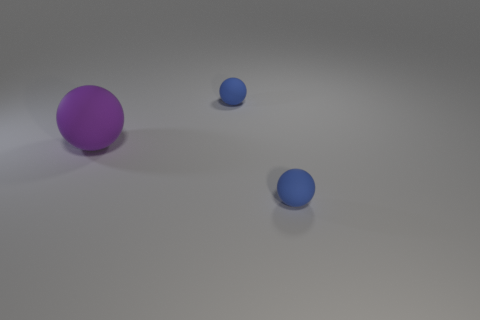What is the relative size of the objects? There is one large purple sphere, a medium-sized blue sphere, and two smaller blue spheres. The medium-sized blue sphere is the closest to the purple one. 